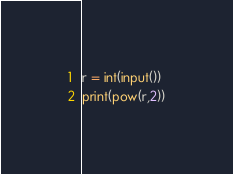Convert code to text. <code><loc_0><loc_0><loc_500><loc_500><_Python_>r = int(input())
print(pow(r,2))</code> 